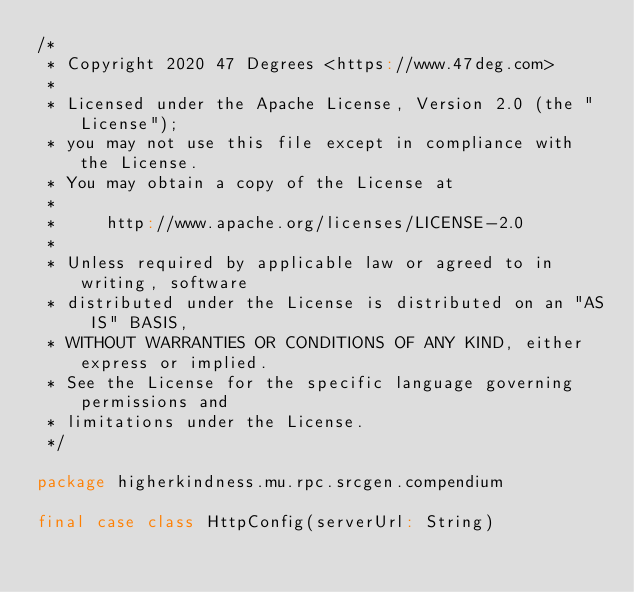<code> <loc_0><loc_0><loc_500><loc_500><_Scala_>/*
 * Copyright 2020 47 Degrees <https://www.47deg.com>
 *
 * Licensed under the Apache License, Version 2.0 (the "License");
 * you may not use this file except in compliance with the License.
 * You may obtain a copy of the License at
 *
 *     http://www.apache.org/licenses/LICENSE-2.0
 *
 * Unless required by applicable law or agreed to in writing, software
 * distributed under the License is distributed on an "AS IS" BASIS,
 * WITHOUT WARRANTIES OR CONDITIONS OF ANY KIND, either express or implied.
 * See the License for the specific language governing permissions and
 * limitations under the License.
 */

package higherkindness.mu.rpc.srcgen.compendium

final case class HttpConfig(serverUrl: String)
</code> 